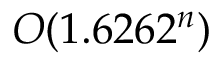<formula> <loc_0><loc_0><loc_500><loc_500>O ( 1 . 6 2 6 2 ^ { n } )</formula> 